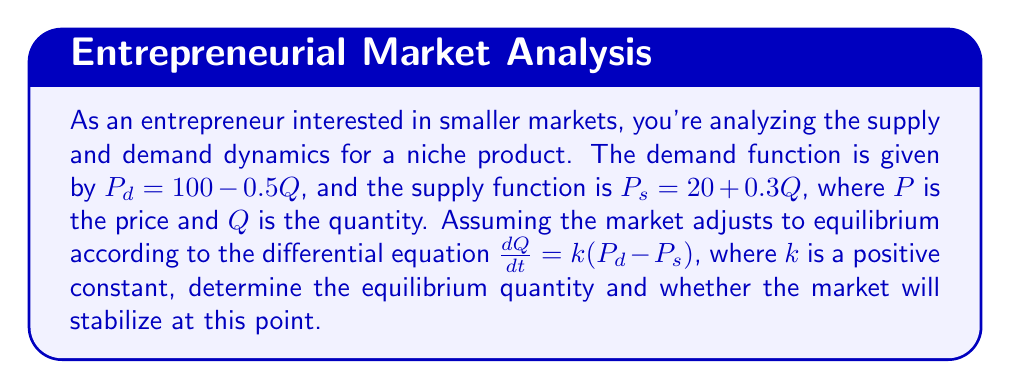What is the answer to this math problem? 1) First, let's find the equilibrium point by setting $P_d = P_s$:

   $100 - 0.5Q = 20 + 0.3Q$
   $80 = 0.8Q$
   $Q_{eq} = 100$

2) Now, let's substitute the demand and supply functions into the differential equation:

   $\frac{dQ}{dt} = k(P_d - P_s)$
   $\frac{dQ}{dt} = k((100 - 0.5Q) - (20 + 0.3Q))$
   $\frac{dQ}{dt} = k(80 - 0.8Q)$

3) To analyze stability, we can rewrite this as:

   $\frac{dQ}{dt} = k(80 - 0.8Q) = -0.8k(Q - 100)$

4) This is a linear first-order differential equation of the form:

   $\frac{dQ}{dt} = -a(Q - Q_{eq})$

   Where $a = 0.8k > 0$ (since $k$ is positive).

5) The solution to this differential equation is:

   $Q(t) = Q_{eq} + (Q_0 - Q_{eq})e^{-at}$

   Where $Q_0$ is the initial quantity.

6) As $t \to \infty$, $e^{-at} \to 0$, so $Q(t) \to Q_{eq} = 100$.

Therefore, the market will stabilize at the equilibrium point $Q_{eq} = 100$.
Answer: Equilibrium quantity: 100; Market will stabilize. 